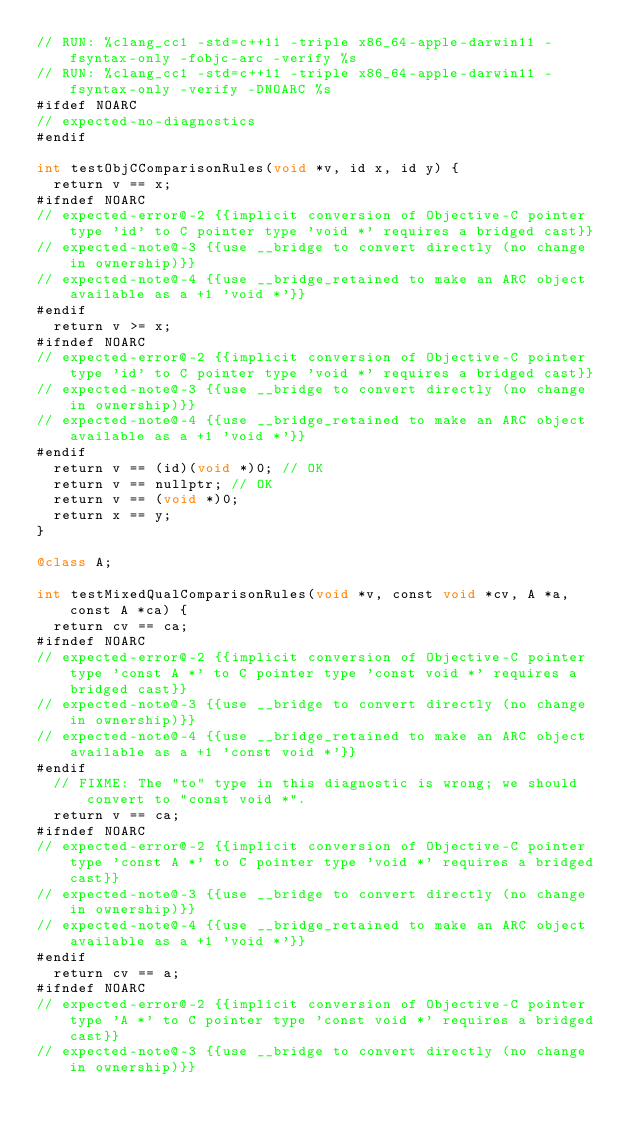<code> <loc_0><loc_0><loc_500><loc_500><_ObjectiveC_>// RUN: %clang_cc1 -std=c++11 -triple x86_64-apple-darwin11 -fsyntax-only -fobjc-arc -verify %s
// RUN: %clang_cc1 -std=c++11 -triple x86_64-apple-darwin11 -fsyntax-only -verify -DNOARC %s
#ifdef NOARC
// expected-no-diagnostics
#endif

int testObjCComparisonRules(void *v, id x, id y) {
  return v == x;
#ifndef NOARC
// expected-error@-2 {{implicit conversion of Objective-C pointer type 'id' to C pointer type 'void *' requires a bridged cast}}
// expected-note@-3 {{use __bridge to convert directly (no change in ownership)}}
// expected-note@-4 {{use __bridge_retained to make an ARC object available as a +1 'void *'}}
#endif
  return v >= x;
#ifndef NOARC
// expected-error@-2 {{implicit conversion of Objective-C pointer type 'id' to C pointer type 'void *' requires a bridged cast}}
// expected-note@-3 {{use __bridge to convert directly (no change in ownership)}}
// expected-note@-4 {{use __bridge_retained to make an ARC object available as a +1 'void *'}}
#endif
  return v == (id)(void *)0; // OK
  return v == nullptr; // OK
  return v == (void *)0;
  return x == y;
}

@class A;

int testMixedQualComparisonRules(void *v, const void *cv, A *a, const A *ca) {
  return cv == ca;
#ifndef NOARC
// expected-error@-2 {{implicit conversion of Objective-C pointer type 'const A *' to C pointer type 'const void *' requires a bridged cast}}
// expected-note@-3 {{use __bridge to convert directly (no change in ownership)}}
// expected-note@-4 {{use __bridge_retained to make an ARC object available as a +1 'const void *'}}
#endif
  // FIXME: The "to" type in this diagnostic is wrong; we should convert to "const void *".
  return v == ca;
#ifndef NOARC
// expected-error@-2 {{implicit conversion of Objective-C pointer type 'const A *' to C pointer type 'void *' requires a bridged cast}}
// expected-note@-3 {{use __bridge to convert directly (no change in ownership)}}
// expected-note@-4 {{use __bridge_retained to make an ARC object available as a +1 'void *'}}
#endif
  return cv == a;
#ifndef NOARC
// expected-error@-2 {{implicit conversion of Objective-C pointer type 'A *' to C pointer type 'const void *' requires a bridged cast}}
// expected-note@-3 {{use __bridge to convert directly (no change in ownership)}}</code> 